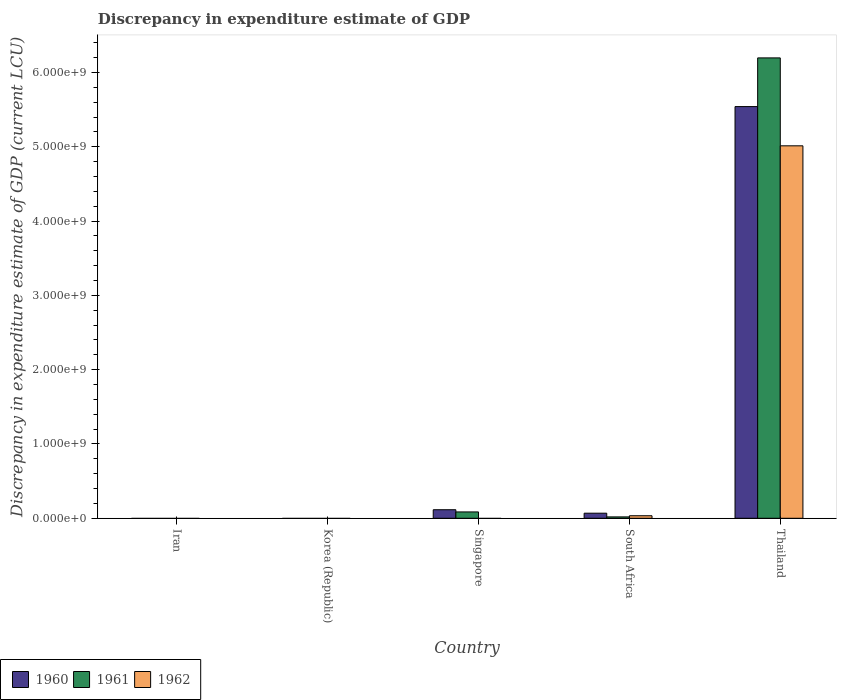Are the number of bars on each tick of the X-axis equal?
Give a very brief answer. No. How many bars are there on the 5th tick from the left?
Offer a very short reply. 3. How many bars are there on the 5th tick from the right?
Ensure brevity in your answer.  0. What is the label of the 4th group of bars from the left?
Your response must be concise. South Africa. In how many cases, is the number of bars for a given country not equal to the number of legend labels?
Offer a very short reply. 3. What is the discrepancy in expenditure estimate of GDP in 1960 in Singapore?
Your response must be concise. 1.15e+08. Across all countries, what is the maximum discrepancy in expenditure estimate of GDP in 1961?
Provide a succinct answer. 6.20e+09. In which country was the discrepancy in expenditure estimate of GDP in 1960 maximum?
Provide a short and direct response. Thailand. What is the total discrepancy in expenditure estimate of GDP in 1960 in the graph?
Ensure brevity in your answer.  5.72e+09. What is the difference between the discrepancy in expenditure estimate of GDP in 1960 in Singapore and that in Thailand?
Offer a very short reply. -5.43e+09. What is the difference between the discrepancy in expenditure estimate of GDP in 1961 in Singapore and the discrepancy in expenditure estimate of GDP in 1960 in Korea (Republic)?
Make the answer very short. 8.53e+07. What is the average discrepancy in expenditure estimate of GDP in 1960 per country?
Provide a short and direct response. 1.14e+09. What is the difference between the discrepancy in expenditure estimate of GDP of/in 1960 and discrepancy in expenditure estimate of GDP of/in 1962 in Thailand?
Your response must be concise. 5.28e+08. What is the ratio of the discrepancy in expenditure estimate of GDP in 1961 in South Africa to that in Thailand?
Give a very brief answer. 0. What is the difference between the highest and the second highest discrepancy in expenditure estimate of GDP in 1960?
Your answer should be compact. 4.66e+07. What is the difference between the highest and the lowest discrepancy in expenditure estimate of GDP in 1961?
Offer a very short reply. 6.20e+09. In how many countries, is the discrepancy in expenditure estimate of GDP in 1960 greater than the average discrepancy in expenditure estimate of GDP in 1960 taken over all countries?
Ensure brevity in your answer.  1. Is the sum of the discrepancy in expenditure estimate of GDP in 1960 in South Africa and Thailand greater than the maximum discrepancy in expenditure estimate of GDP in 1962 across all countries?
Your response must be concise. Yes. Is it the case that in every country, the sum of the discrepancy in expenditure estimate of GDP in 1962 and discrepancy in expenditure estimate of GDP in 1960 is greater than the discrepancy in expenditure estimate of GDP in 1961?
Give a very brief answer. No. How many bars are there?
Give a very brief answer. 8. Are all the bars in the graph horizontal?
Make the answer very short. No. Are the values on the major ticks of Y-axis written in scientific E-notation?
Your answer should be very brief. Yes. Does the graph contain any zero values?
Provide a succinct answer. Yes. What is the title of the graph?
Your answer should be compact. Discrepancy in expenditure estimate of GDP. Does "1985" appear as one of the legend labels in the graph?
Your answer should be compact. No. What is the label or title of the Y-axis?
Your answer should be compact. Discrepancy in expenditure estimate of GDP (current LCU). What is the Discrepancy in expenditure estimate of GDP (current LCU) of 1961 in Korea (Republic)?
Your answer should be compact. 0. What is the Discrepancy in expenditure estimate of GDP (current LCU) of 1960 in Singapore?
Provide a succinct answer. 1.15e+08. What is the Discrepancy in expenditure estimate of GDP (current LCU) of 1961 in Singapore?
Make the answer very short. 8.53e+07. What is the Discrepancy in expenditure estimate of GDP (current LCU) of 1962 in Singapore?
Keep it short and to the point. 0. What is the Discrepancy in expenditure estimate of GDP (current LCU) in 1960 in South Africa?
Give a very brief answer. 6.83e+07. What is the Discrepancy in expenditure estimate of GDP (current LCU) in 1961 in South Africa?
Provide a succinct answer. 1.84e+07. What is the Discrepancy in expenditure estimate of GDP (current LCU) in 1962 in South Africa?
Offer a very short reply. 3.40e+07. What is the Discrepancy in expenditure estimate of GDP (current LCU) in 1960 in Thailand?
Your response must be concise. 5.54e+09. What is the Discrepancy in expenditure estimate of GDP (current LCU) of 1961 in Thailand?
Your answer should be very brief. 6.20e+09. What is the Discrepancy in expenditure estimate of GDP (current LCU) of 1962 in Thailand?
Your answer should be very brief. 5.01e+09. Across all countries, what is the maximum Discrepancy in expenditure estimate of GDP (current LCU) of 1960?
Provide a succinct answer. 5.54e+09. Across all countries, what is the maximum Discrepancy in expenditure estimate of GDP (current LCU) of 1961?
Keep it short and to the point. 6.20e+09. Across all countries, what is the maximum Discrepancy in expenditure estimate of GDP (current LCU) in 1962?
Your answer should be compact. 5.01e+09. Across all countries, what is the minimum Discrepancy in expenditure estimate of GDP (current LCU) of 1960?
Offer a terse response. 0. Across all countries, what is the minimum Discrepancy in expenditure estimate of GDP (current LCU) in 1961?
Offer a terse response. 0. Across all countries, what is the minimum Discrepancy in expenditure estimate of GDP (current LCU) of 1962?
Offer a very short reply. 0. What is the total Discrepancy in expenditure estimate of GDP (current LCU) in 1960 in the graph?
Your answer should be very brief. 5.72e+09. What is the total Discrepancy in expenditure estimate of GDP (current LCU) of 1961 in the graph?
Make the answer very short. 6.30e+09. What is the total Discrepancy in expenditure estimate of GDP (current LCU) in 1962 in the graph?
Your answer should be compact. 5.05e+09. What is the difference between the Discrepancy in expenditure estimate of GDP (current LCU) in 1960 in Singapore and that in South Africa?
Make the answer very short. 4.66e+07. What is the difference between the Discrepancy in expenditure estimate of GDP (current LCU) in 1961 in Singapore and that in South Africa?
Your response must be concise. 6.69e+07. What is the difference between the Discrepancy in expenditure estimate of GDP (current LCU) in 1960 in Singapore and that in Thailand?
Offer a very short reply. -5.43e+09. What is the difference between the Discrepancy in expenditure estimate of GDP (current LCU) of 1961 in Singapore and that in Thailand?
Your answer should be very brief. -6.11e+09. What is the difference between the Discrepancy in expenditure estimate of GDP (current LCU) of 1960 in South Africa and that in Thailand?
Provide a succinct answer. -5.47e+09. What is the difference between the Discrepancy in expenditure estimate of GDP (current LCU) in 1961 in South Africa and that in Thailand?
Your answer should be compact. -6.18e+09. What is the difference between the Discrepancy in expenditure estimate of GDP (current LCU) of 1962 in South Africa and that in Thailand?
Offer a very short reply. -4.98e+09. What is the difference between the Discrepancy in expenditure estimate of GDP (current LCU) in 1960 in Singapore and the Discrepancy in expenditure estimate of GDP (current LCU) in 1961 in South Africa?
Offer a very short reply. 9.65e+07. What is the difference between the Discrepancy in expenditure estimate of GDP (current LCU) in 1960 in Singapore and the Discrepancy in expenditure estimate of GDP (current LCU) in 1962 in South Africa?
Provide a short and direct response. 8.09e+07. What is the difference between the Discrepancy in expenditure estimate of GDP (current LCU) of 1961 in Singapore and the Discrepancy in expenditure estimate of GDP (current LCU) of 1962 in South Africa?
Give a very brief answer. 5.13e+07. What is the difference between the Discrepancy in expenditure estimate of GDP (current LCU) in 1960 in Singapore and the Discrepancy in expenditure estimate of GDP (current LCU) in 1961 in Thailand?
Keep it short and to the point. -6.08e+09. What is the difference between the Discrepancy in expenditure estimate of GDP (current LCU) of 1960 in Singapore and the Discrepancy in expenditure estimate of GDP (current LCU) of 1962 in Thailand?
Offer a terse response. -4.90e+09. What is the difference between the Discrepancy in expenditure estimate of GDP (current LCU) in 1961 in Singapore and the Discrepancy in expenditure estimate of GDP (current LCU) in 1962 in Thailand?
Make the answer very short. -4.93e+09. What is the difference between the Discrepancy in expenditure estimate of GDP (current LCU) in 1960 in South Africa and the Discrepancy in expenditure estimate of GDP (current LCU) in 1961 in Thailand?
Offer a very short reply. -6.13e+09. What is the difference between the Discrepancy in expenditure estimate of GDP (current LCU) of 1960 in South Africa and the Discrepancy in expenditure estimate of GDP (current LCU) of 1962 in Thailand?
Your answer should be compact. -4.95e+09. What is the difference between the Discrepancy in expenditure estimate of GDP (current LCU) in 1961 in South Africa and the Discrepancy in expenditure estimate of GDP (current LCU) in 1962 in Thailand?
Offer a very short reply. -5.00e+09. What is the average Discrepancy in expenditure estimate of GDP (current LCU) of 1960 per country?
Your answer should be very brief. 1.14e+09. What is the average Discrepancy in expenditure estimate of GDP (current LCU) in 1961 per country?
Ensure brevity in your answer.  1.26e+09. What is the average Discrepancy in expenditure estimate of GDP (current LCU) of 1962 per country?
Provide a short and direct response. 1.01e+09. What is the difference between the Discrepancy in expenditure estimate of GDP (current LCU) of 1960 and Discrepancy in expenditure estimate of GDP (current LCU) of 1961 in Singapore?
Your answer should be compact. 2.96e+07. What is the difference between the Discrepancy in expenditure estimate of GDP (current LCU) of 1960 and Discrepancy in expenditure estimate of GDP (current LCU) of 1961 in South Africa?
Offer a terse response. 4.99e+07. What is the difference between the Discrepancy in expenditure estimate of GDP (current LCU) of 1960 and Discrepancy in expenditure estimate of GDP (current LCU) of 1962 in South Africa?
Provide a succinct answer. 3.43e+07. What is the difference between the Discrepancy in expenditure estimate of GDP (current LCU) in 1961 and Discrepancy in expenditure estimate of GDP (current LCU) in 1962 in South Africa?
Ensure brevity in your answer.  -1.56e+07. What is the difference between the Discrepancy in expenditure estimate of GDP (current LCU) of 1960 and Discrepancy in expenditure estimate of GDP (current LCU) of 1961 in Thailand?
Offer a terse response. -6.56e+08. What is the difference between the Discrepancy in expenditure estimate of GDP (current LCU) in 1960 and Discrepancy in expenditure estimate of GDP (current LCU) in 1962 in Thailand?
Provide a short and direct response. 5.28e+08. What is the difference between the Discrepancy in expenditure estimate of GDP (current LCU) in 1961 and Discrepancy in expenditure estimate of GDP (current LCU) in 1962 in Thailand?
Provide a succinct answer. 1.18e+09. What is the ratio of the Discrepancy in expenditure estimate of GDP (current LCU) of 1960 in Singapore to that in South Africa?
Your answer should be compact. 1.68. What is the ratio of the Discrepancy in expenditure estimate of GDP (current LCU) in 1961 in Singapore to that in South Africa?
Give a very brief answer. 4.64. What is the ratio of the Discrepancy in expenditure estimate of GDP (current LCU) of 1960 in Singapore to that in Thailand?
Provide a succinct answer. 0.02. What is the ratio of the Discrepancy in expenditure estimate of GDP (current LCU) of 1961 in Singapore to that in Thailand?
Give a very brief answer. 0.01. What is the ratio of the Discrepancy in expenditure estimate of GDP (current LCU) in 1960 in South Africa to that in Thailand?
Provide a succinct answer. 0.01. What is the ratio of the Discrepancy in expenditure estimate of GDP (current LCU) of 1961 in South Africa to that in Thailand?
Your answer should be compact. 0. What is the ratio of the Discrepancy in expenditure estimate of GDP (current LCU) of 1962 in South Africa to that in Thailand?
Keep it short and to the point. 0.01. What is the difference between the highest and the second highest Discrepancy in expenditure estimate of GDP (current LCU) of 1960?
Offer a terse response. 5.43e+09. What is the difference between the highest and the second highest Discrepancy in expenditure estimate of GDP (current LCU) of 1961?
Keep it short and to the point. 6.11e+09. What is the difference between the highest and the lowest Discrepancy in expenditure estimate of GDP (current LCU) in 1960?
Your answer should be very brief. 5.54e+09. What is the difference between the highest and the lowest Discrepancy in expenditure estimate of GDP (current LCU) in 1961?
Your answer should be compact. 6.20e+09. What is the difference between the highest and the lowest Discrepancy in expenditure estimate of GDP (current LCU) of 1962?
Provide a succinct answer. 5.01e+09. 